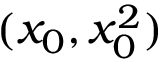<formula> <loc_0><loc_0><loc_500><loc_500>( x _ { 0 } , x _ { 0 } ^ { 2 } )</formula> 